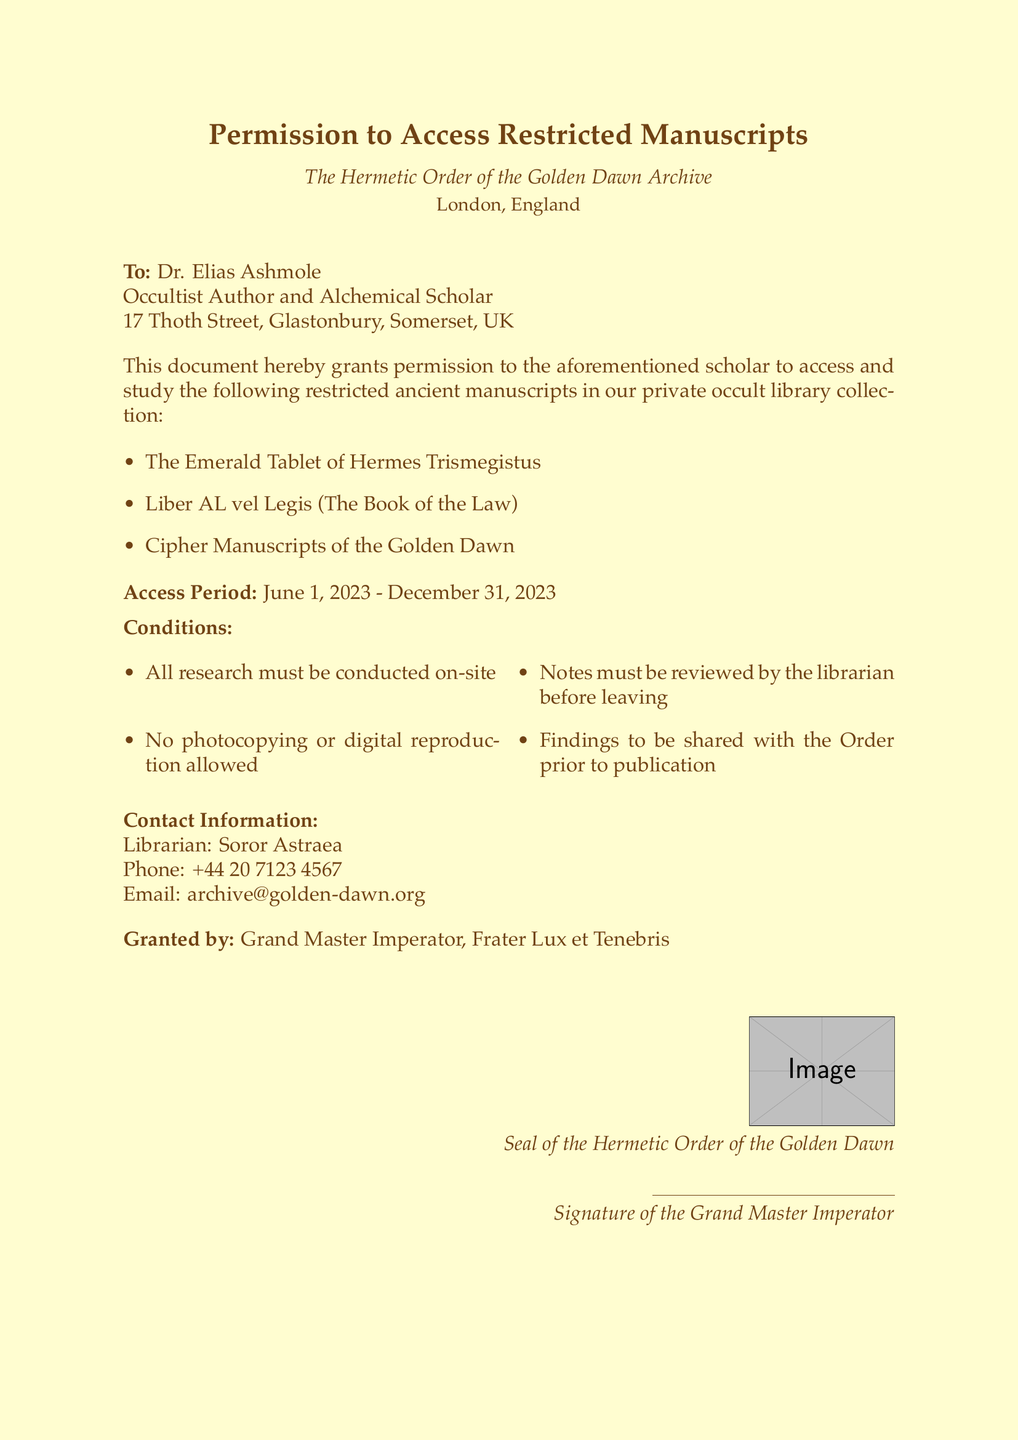What is the title of the document? The title is prominently displayed at the beginning of the document and summarizes its purpose.
Answer: Permission to Access Restricted Manuscripts Who is the recipient of this permission? The recipient's name is stated directly in the salutation of the document.
Answer: Dr. Elias Ashmole What is the access period for the manuscripts? The access period is mentioned in the document and specifies the duration for which access is granted.
Answer: June 1, 2023 - December 31, 2023 What manuscripts are included in this permission? The list of manuscripts is provided in a bullet-point format within the document.
Answer: The Emerald Tablet of Hermes Trismegistus, Liber AL vel Legis, Cipher Manuscripts of the Golden Dawn Who is the contact librarian for this permission? The librarian's name is noted in the contact information section of the document.
Answer: Soror Astraea What is one of the research conditions? The conditions for research are outlined in a bulleted list within the document.
Answer: All research must be conducted on-site Who granted this permission? The name of the person granting the permission is included at the end of the document.
Answer: Grand Master Imperator, Frater Lux et Tenebris What is not allowed during the research? The document specifies prohibitions in a list format regarding the research process.
Answer: No photocopying or digital reproduction allowed What is the email address for contacting the librarian? The document provides the librarian's email address as part of the contact information section.
Answer: archive@golden-dawn.org 